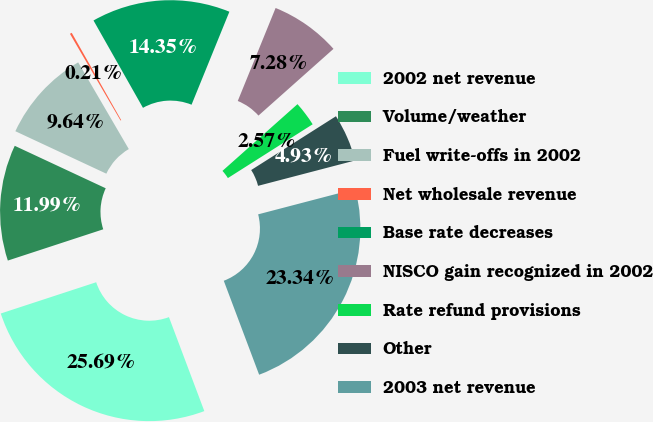Convert chart to OTSL. <chart><loc_0><loc_0><loc_500><loc_500><pie_chart><fcel>2002 net revenue<fcel>Volume/weather<fcel>Fuel write-offs in 2002<fcel>Net wholesale revenue<fcel>Base rate decreases<fcel>NISCO gain recognized in 2002<fcel>Rate refund provisions<fcel>Other<fcel>2003 net revenue<nl><fcel>25.69%<fcel>11.99%<fcel>9.64%<fcel>0.21%<fcel>14.35%<fcel>7.28%<fcel>2.57%<fcel>4.93%<fcel>23.34%<nl></chart> 